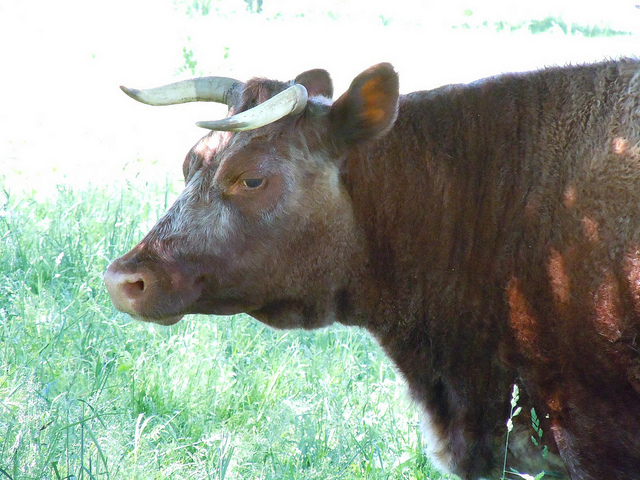What kind of bull is this? The image appears to show a bovine with distinctively shaped horns which could suggest it is a Longhorn, a breed characterized by its long and curved horns. Typically, Longhorns display a variety of coat colors, and the individual in the image has a brownish coat, which is consistent with the breed's attributes. 